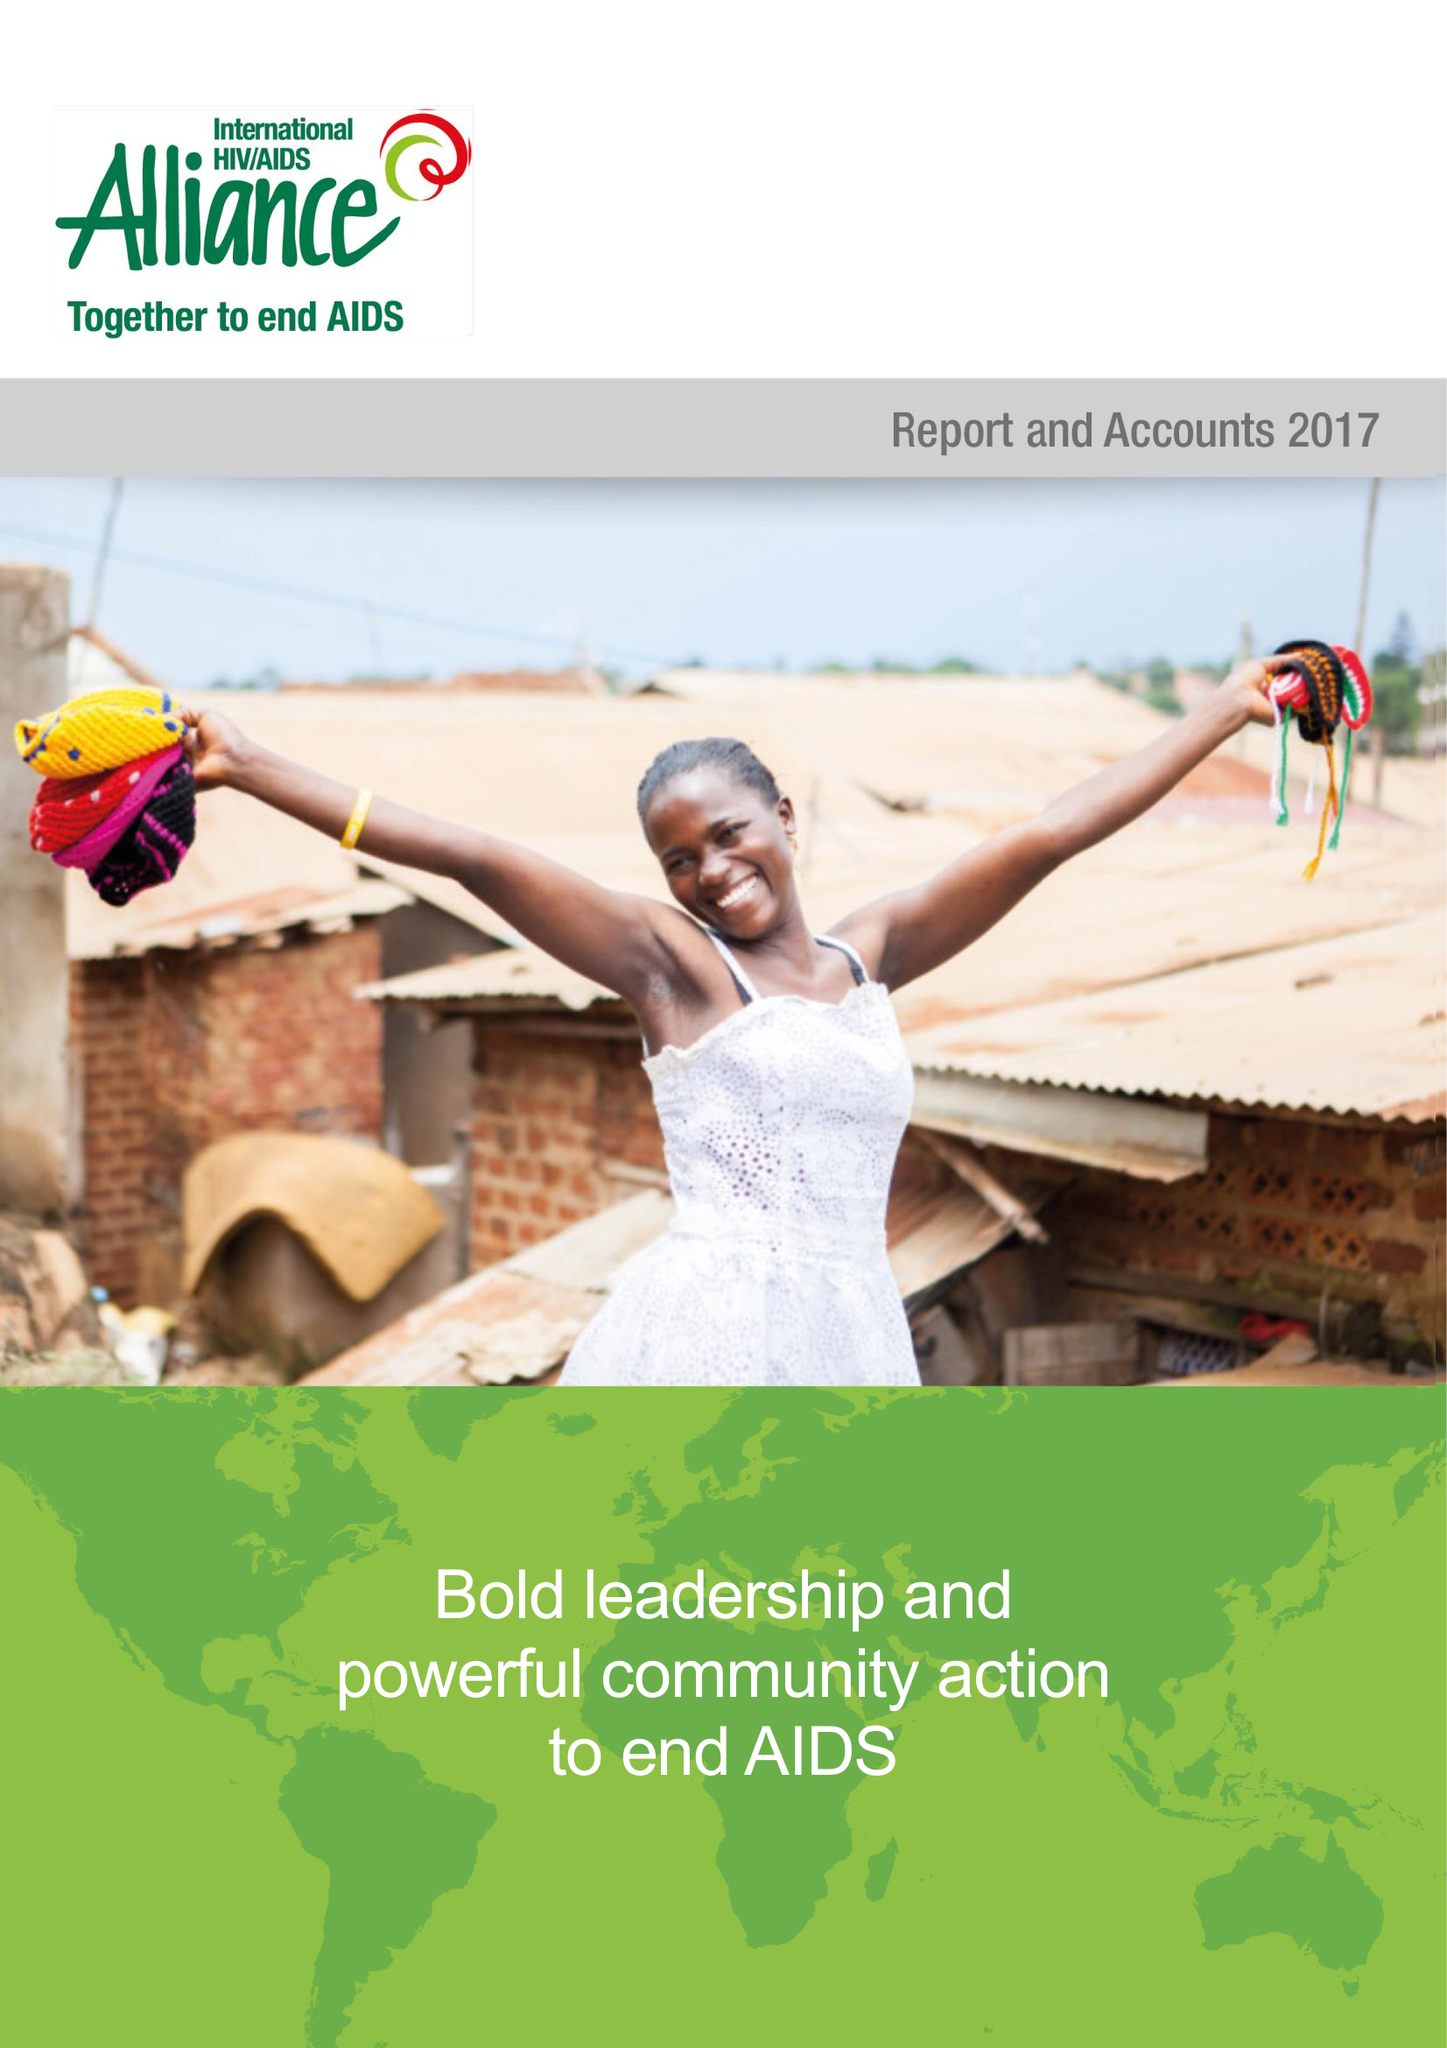What is the value for the spending_annually_in_british_pounds?
Answer the question using a single word or phrase. 17065487.00 